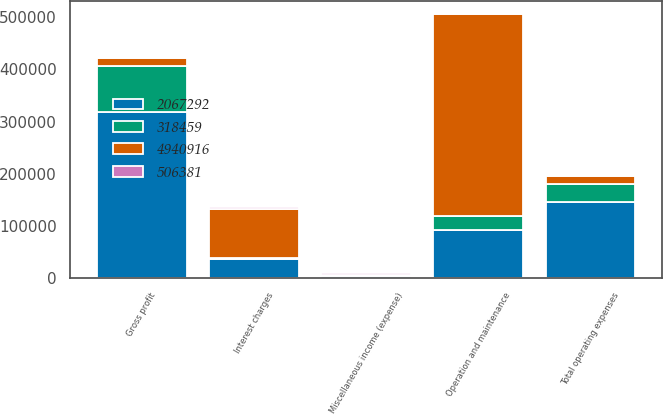Convert chart. <chart><loc_0><loc_0><loc_500><loc_500><stacked_bar_chart><ecel><fcel>Gross profit<fcel>Operation and maintenance<fcel>Total operating expenses<fcel>Miscellaneous income (expense)<fcel>Interest charges<nl><fcel>4.94092e+06<fcel>15426<fcel>387228<fcel>15426<fcel>381<fcel>94918<nl><fcel>2.06729e+06<fcel>318459<fcel>91466<fcel>145640<fcel>3181<fcel>36280<nl><fcel>318459<fcel>87955<fcel>26963<fcel>33993<fcel>2216<fcel>1986<nl><fcel>506381<fcel>503<fcel>503<fcel>503<fcel>3889<fcel>3889<nl></chart> 